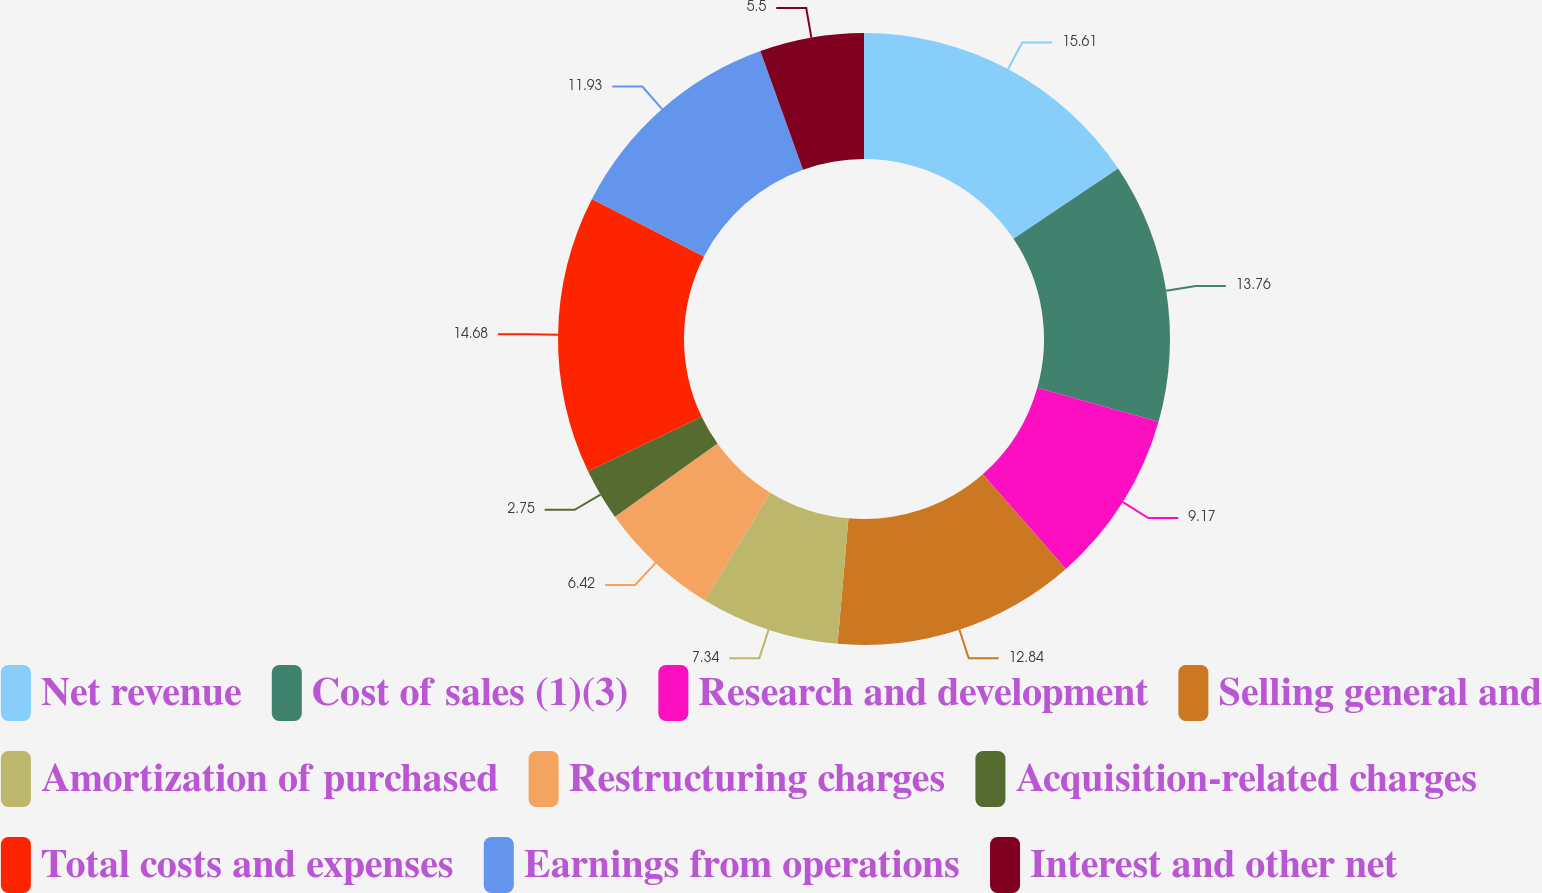Convert chart. <chart><loc_0><loc_0><loc_500><loc_500><pie_chart><fcel>Net revenue<fcel>Cost of sales (1)(3)<fcel>Research and development<fcel>Selling general and<fcel>Amortization of purchased<fcel>Restructuring charges<fcel>Acquisition-related charges<fcel>Total costs and expenses<fcel>Earnings from operations<fcel>Interest and other net<nl><fcel>15.6%<fcel>13.76%<fcel>9.17%<fcel>12.84%<fcel>7.34%<fcel>6.42%<fcel>2.75%<fcel>14.68%<fcel>11.93%<fcel>5.5%<nl></chart> 